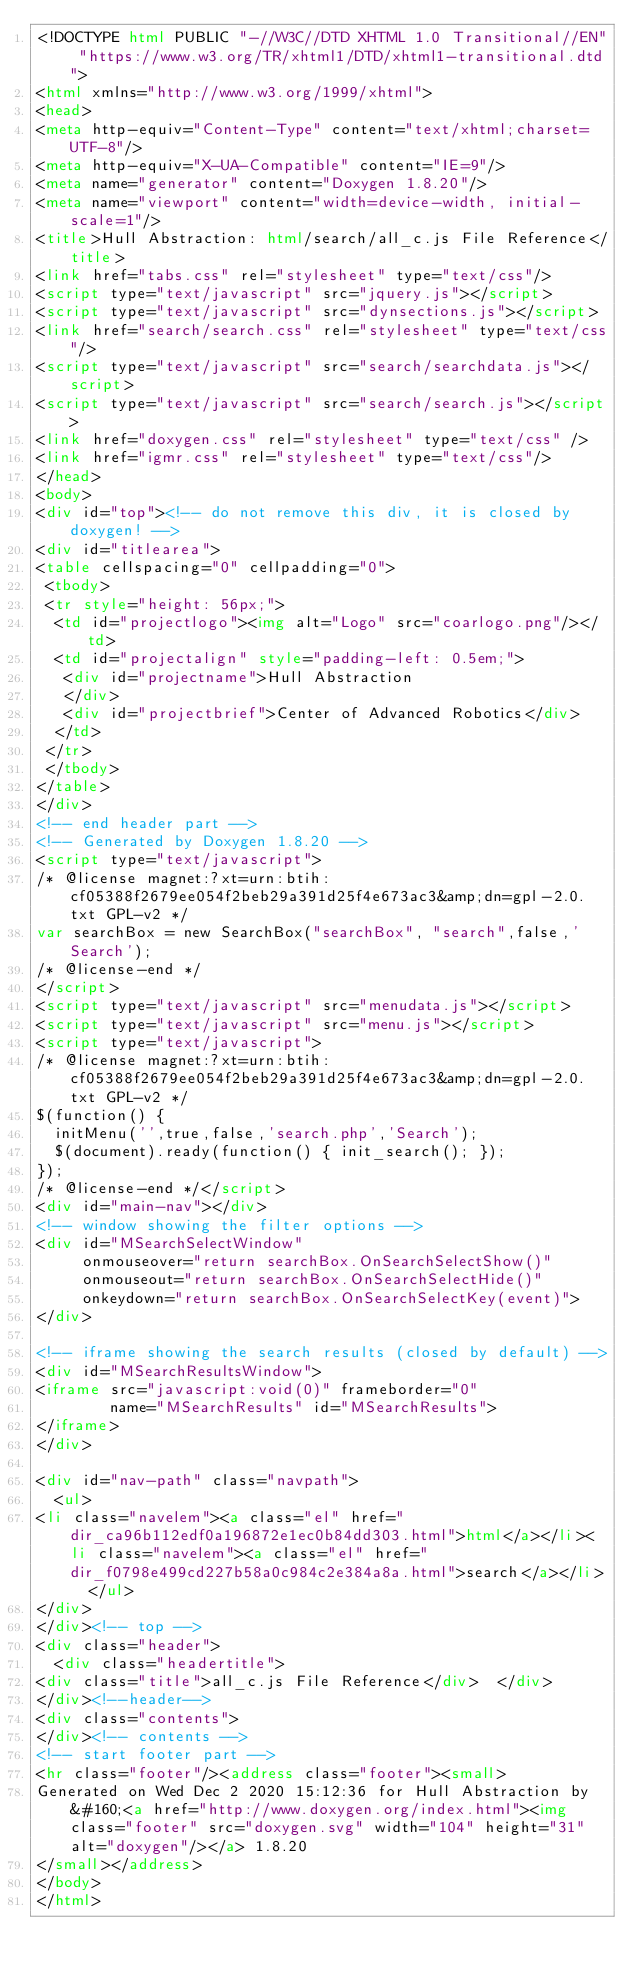<code> <loc_0><loc_0><loc_500><loc_500><_HTML_><!DOCTYPE html PUBLIC "-//W3C//DTD XHTML 1.0 Transitional//EN" "https://www.w3.org/TR/xhtml1/DTD/xhtml1-transitional.dtd">
<html xmlns="http://www.w3.org/1999/xhtml">
<head>
<meta http-equiv="Content-Type" content="text/xhtml;charset=UTF-8"/>
<meta http-equiv="X-UA-Compatible" content="IE=9"/>
<meta name="generator" content="Doxygen 1.8.20"/>
<meta name="viewport" content="width=device-width, initial-scale=1"/>
<title>Hull Abstraction: html/search/all_c.js File Reference</title>
<link href="tabs.css" rel="stylesheet" type="text/css"/>
<script type="text/javascript" src="jquery.js"></script>
<script type="text/javascript" src="dynsections.js"></script>
<link href="search/search.css" rel="stylesheet" type="text/css"/>
<script type="text/javascript" src="search/searchdata.js"></script>
<script type="text/javascript" src="search/search.js"></script>
<link href="doxygen.css" rel="stylesheet" type="text/css" />
<link href="igmr.css" rel="stylesheet" type="text/css"/>
</head>
<body>
<div id="top"><!-- do not remove this div, it is closed by doxygen! -->
<div id="titlearea">
<table cellspacing="0" cellpadding="0">
 <tbody>
 <tr style="height: 56px;">
  <td id="projectlogo"><img alt="Logo" src="coarlogo.png"/></td>
  <td id="projectalign" style="padding-left: 0.5em;">
   <div id="projectname">Hull Abstraction
   </div>
   <div id="projectbrief">Center of Advanced Robotics</div>
  </td>
 </tr>
 </tbody>
</table>
</div>
<!-- end header part -->
<!-- Generated by Doxygen 1.8.20 -->
<script type="text/javascript">
/* @license magnet:?xt=urn:btih:cf05388f2679ee054f2beb29a391d25f4e673ac3&amp;dn=gpl-2.0.txt GPL-v2 */
var searchBox = new SearchBox("searchBox", "search",false,'Search');
/* @license-end */
</script>
<script type="text/javascript" src="menudata.js"></script>
<script type="text/javascript" src="menu.js"></script>
<script type="text/javascript">
/* @license magnet:?xt=urn:btih:cf05388f2679ee054f2beb29a391d25f4e673ac3&amp;dn=gpl-2.0.txt GPL-v2 */
$(function() {
  initMenu('',true,false,'search.php','Search');
  $(document).ready(function() { init_search(); });
});
/* @license-end */</script>
<div id="main-nav"></div>
<!-- window showing the filter options -->
<div id="MSearchSelectWindow"
     onmouseover="return searchBox.OnSearchSelectShow()"
     onmouseout="return searchBox.OnSearchSelectHide()"
     onkeydown="return searchBox.OnSearchSelectKey(event)">
</div>

<!-- iframe showing the search results (closed by default) -->
<div id="MSearchResultsWindow">
<iframe src="javascript:void(0)" frameborder="0" 
        name="MSearchResults" id="MSearchResults">
</iframe>
</div>

<div id="nav-path" class="navpath">
  <ul>
<li class="navelem"><a class="el" href="dir_ca96b112edf0a196872e1ec0b84dd303.html">html</a></li><li class="navelem"><a class="el" href="dir_f0798e499cd227b58a0c984c2e384a8a.html">search</a></li>  </ul>
</div>
</div><!-- top -->
<div class="header">
  <div class="headertitle">
<div class="title">all_c.js File Reference</div>  </div>
</div><!--header-->
<div class="contents">
</div><!-- contents -->
<!-- start footer part -->
<hr class="footer"/><address class="footer"><small>
Generated on Wed Dec 2 2020 15:12:36 for Hull Abstraction by&#160;<a href="http://www.doxygen.org/index.html"><img class="footer" src="doxygen.svg" width="104" height="31" alt="doxygen"/></a> 1.8.20
</small></address>
</body>
</html>
</code> 